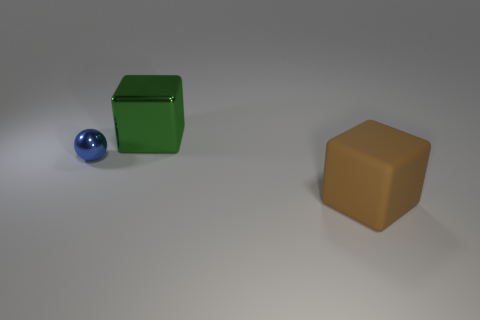What is the shape of the large thing that is in front of the big cube behind the big brown rubber thing?
Provide a short and direct response. Cube. Is the size of the block that is right of the green cube the same as the green metal thing?
Your response must be concise. Yes. What number of other things are the same material as the small sphere?
Offer a terse response. 1. How many blue things are either small metallic spheres or big blocks?
Your response must be concise. 1. What number of blue spheres are behind the blue ball?
Your answer should be compact. 0. There is a blue shiny thing behind the big object in front of the large object that is to the left of the brown thing; what size is it?
Your response must be concise. Small. There is a thing left of the shiny object behind the blue ball; are there any big green things that are on the left side of it?
Give a very brief answer. No. Are there more red things than matte cubes?
Give a very brief answer. No. The block that is left of the big rubber cube is what color?
Make the answer very short. Green. Is the number of objects that are to the left of the metallic block greater than the number of large blue metal cylinders?
Provide a succinct answer. Yes. 